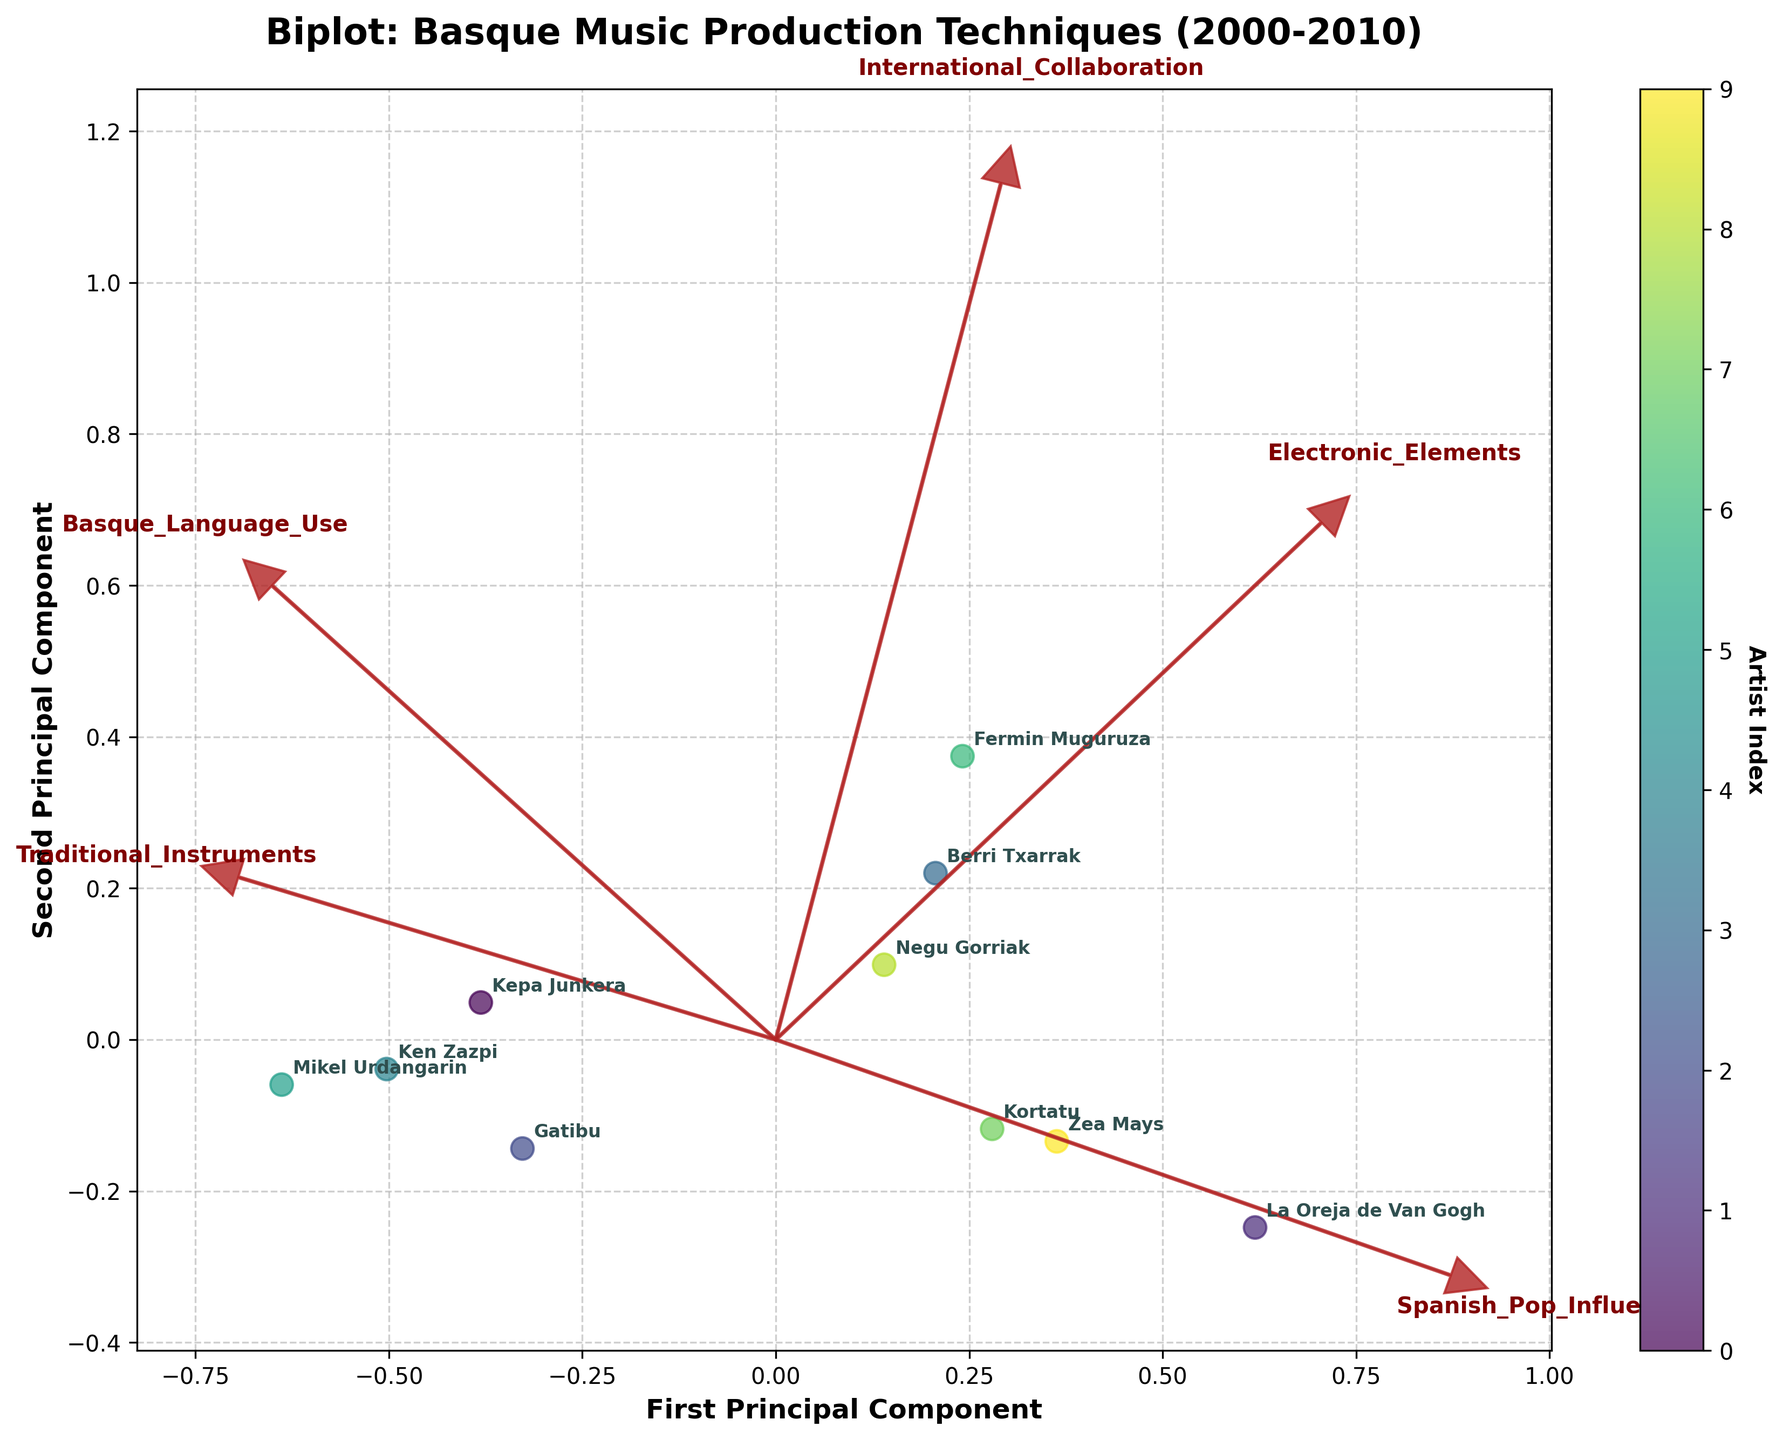How many artists are represented in the biplot? Count the number of distinct labels in the figure. There are 10 unique artists labeled in the biplot.
Answer: 10 What are the axes labeled in the biplot? Check the labels on the x-axis and y-axis. The x-axis is labeled "First Principal Component" and the y-axis is labeled "Second Principal Component".
Answer: First Principal Component, Second Principal Component Which artist is most closely associated with the use of traditional instruments based on their label position? The vector for "Traditional_Instruments" points strongly to the right. The artist label closest to the right in this direction is Kepa Junkera.
Answer: Kepa Junkera Who exhibits the highest influence from Spanish pop music in the biplot? Look at the direction of the "Spanish_Pop_Influence" vector. The artist closest to its endpoint will be the most influenced. La Oreja de Van Gogh is closest to this vector.
Answer: La Oreja de Van Gogh Which two artists are positioned closest to each other in the biplot, indicating similar production techniques? Identify the two labels that are closest together in the scatter plot. Berri Txarrak and Negu Gorriak are positioned closest to each other.
Answer: Berri Txarrak and Negu Gorriak How do traditional instruments and electronic elements relate to each other in the biplot? Look at the relative direction and angle between the "Traditional_Instruments" and "Electronic_Elements" vectors. These vectors are pointing in somewhat different directions, indicating a negative or weak correlation.
Answer: Negative or weak correlation What is the relationship between the variables "Basque_Language_Use" and "International_Collaboration"? Inspect the relative direction of the vectors for "Basque_Language_Use" and "International_Collaboration". The vectors are pointed somewhat in different directions, suggesting a weaker relationship.
Answer: Weak or no strong correlation Which artist has the least association with the use of the Basque language? Find the direction of the "Basque_Language_Use" vector and identify the artist furthest away from this direction. La Oreja de Van Gogh is furthest from this vector.
Answer: La Oreja de Van Gogh Which variables seem to most influence the first principal component? Look at the lengths and directions of the vectors along the x-axis. "Traditional_Instruments" and "Spanish_Pop_Influence" appear the most influential based on their vector length and alignment with the first principal component.
Answer: Traditional_Instruments, Spanish_Pop_Influence 